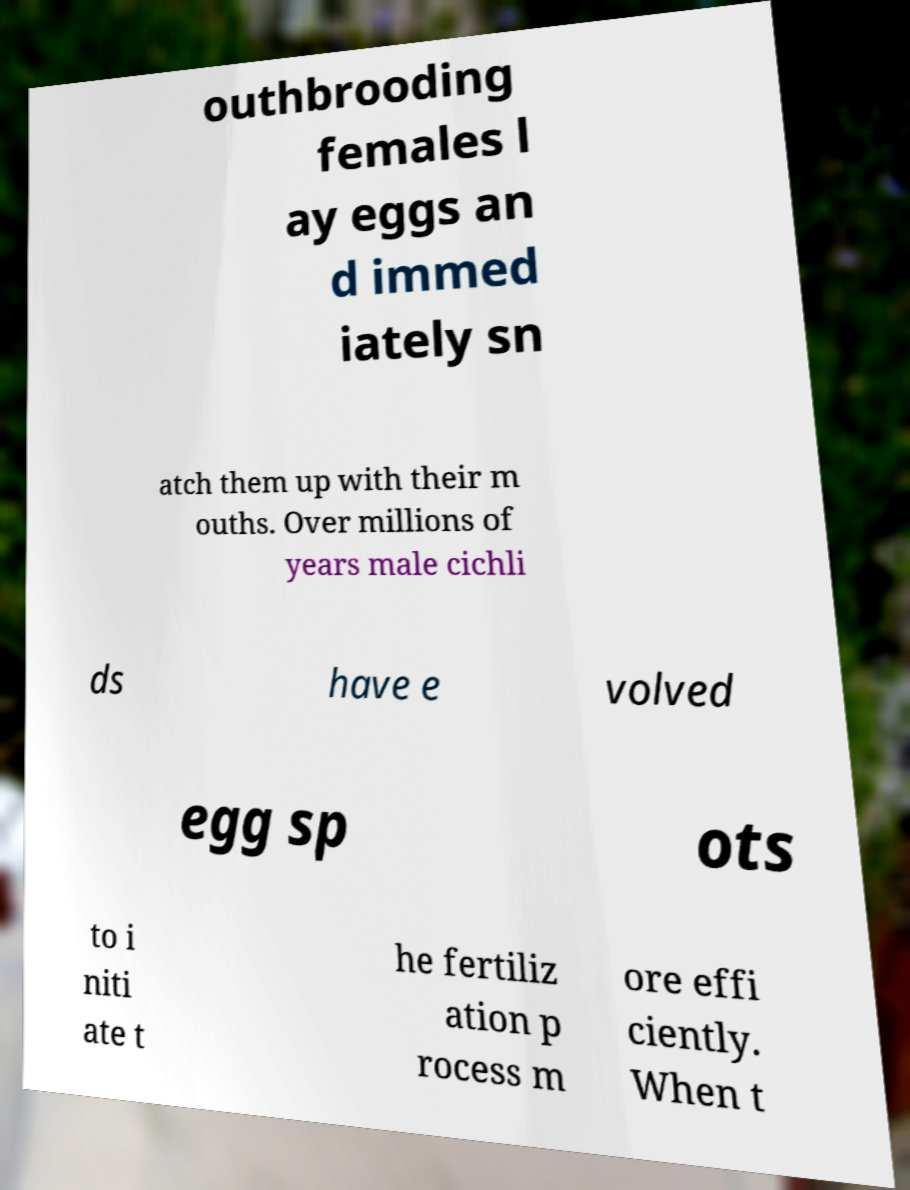Please identify and transcribe the text found in this image. outhbrooding females l ay eggs an d immed iately sn atch them up with their m ouths. Over millions of years male cichli ds have e volved egg sp ots to i niti ate t he fertiliz ation p rocess m ore effi ciently. When t 